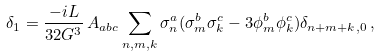Convert formula to latex. <formula><loc_0><loc_0><loc_500><loc_500>\delta _ { 1 } = \frac { - i L } { 3 2 G ^ { 3 } } \, A _ { a b c } \sum _ { n , m , k } \sigma ^ { a } _ { n } ( \sigma ^ { b } _ { m } \sigma ^ { c } _ { k } - 3 \phi ^ { b } _ { m } \phi ^ { c } _ { k } ) \delta _ { n + m + k , 0 } \, ,</formula> 